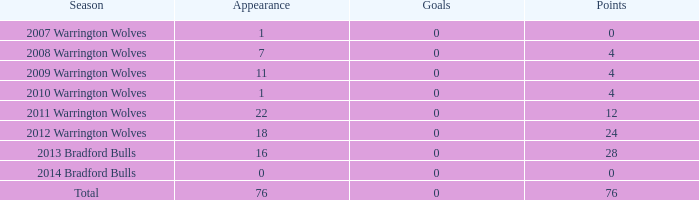What is the minimum occurrence when the goal count is above 0? None. 